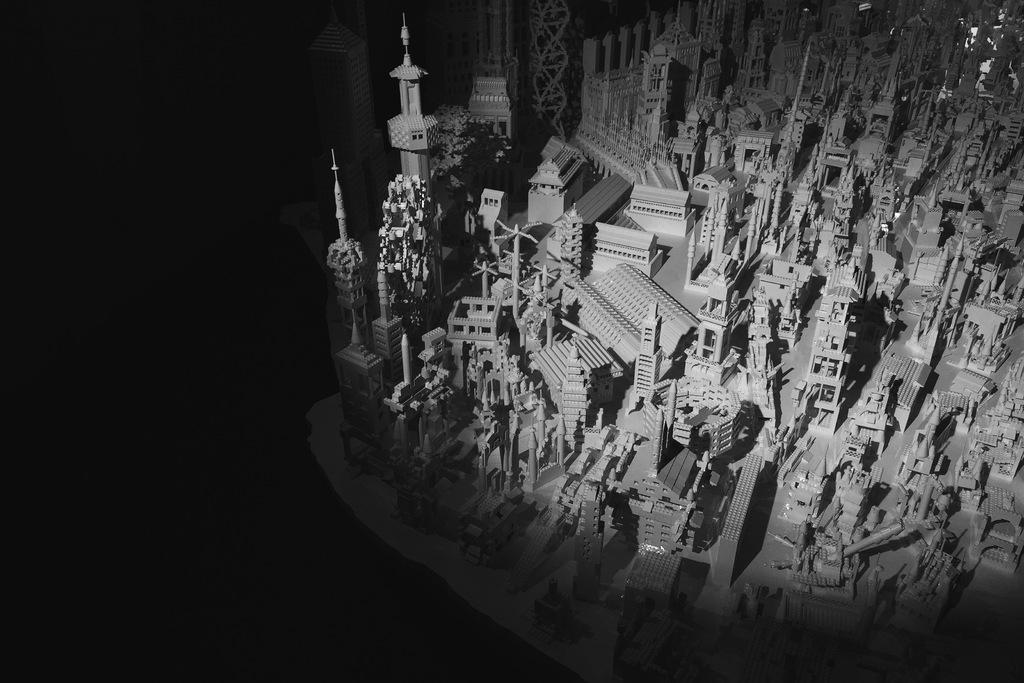What type of objects are depicted in the image? There are miniatures of buildings and towers in the image. Can you describe the background of the image? The background of the image is dark. What type of kitty can be seen teaching in the image? There is no kitty or teaching activity present in the image. 